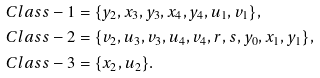Convert formula to latex. <formula><loc_0><loc_0><loc_500><loc_500>C l a s s - 1 & = \{ y _ { 2 } , x _ { 3 } , y _ { 3 } , x _ { 4 } , y _ { 4 } , u _ { 1 } , v _ { 1 } \} , \\ C l a s s - 2 & = \{ v _ { 2 } , u _ { 3 } , v _ { 3 } , u _ { 4 } , v _ { 4 } , r , s , y _ { 0 } , x _ { 1 } , y _ { 1 } \} , \\ C l a s s - 3 & = \{ x _ { 2 } , u _ { 2 } \} .</formula> 